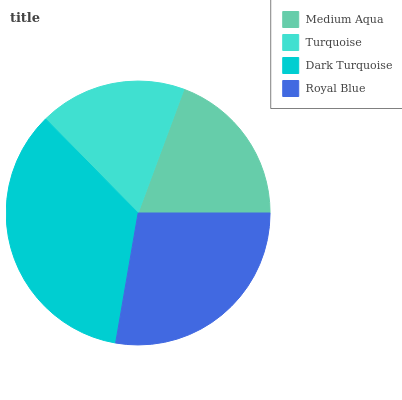Is Turquoise the minimum?
Answer yes or no. Yes. Is Dark Turquoise the maximum?
Answer yes or no. Yes. Is Dark Turquoise the minimum?
Answer yes or no. No. Is Turquoise the maximum?
Answer yes or no. No. Is Dark Turquoise greater than Turquoise?
Answer yes or no. Yes. Is Turquoise less than Dark Turquoise?
Answer yes or no. Yes. Is Turquoise greater than Dark Turquoise?
Answer yes or no. No. Is Dark Turquoise less than Turquoise?
Answer yes or no. No. Is Royal Blue the high median?
Answer yes or no. Yes. Is Medium Aqua the low median?
Answer yes or no. Yes. Is Medium Aqua the high median?
Answer yes or no. No. Is Royal Blue the low median?
Answer yes or no. No. 